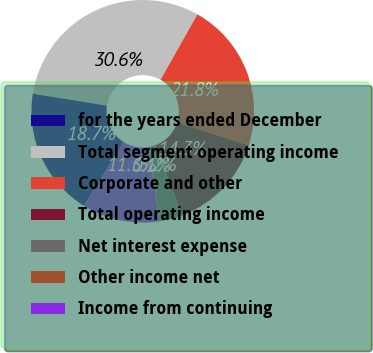<chart> <loc_0><loc_0><loc_500><loc_500><pie_chart><fcel>for the years ended December<fcel>Total segment operating income<fcel>Corporate and other<fcel>Total operating income<fcel>Net interest expense<fcel>Other income net<fcel>Income from continuing<nl><fcel>18.7%<fcel>30.62%<fcel>21.75%<fcel>14.33%<fcel>3.18%<fcel>0.13%<fcel>11.28%<nl></chart> 